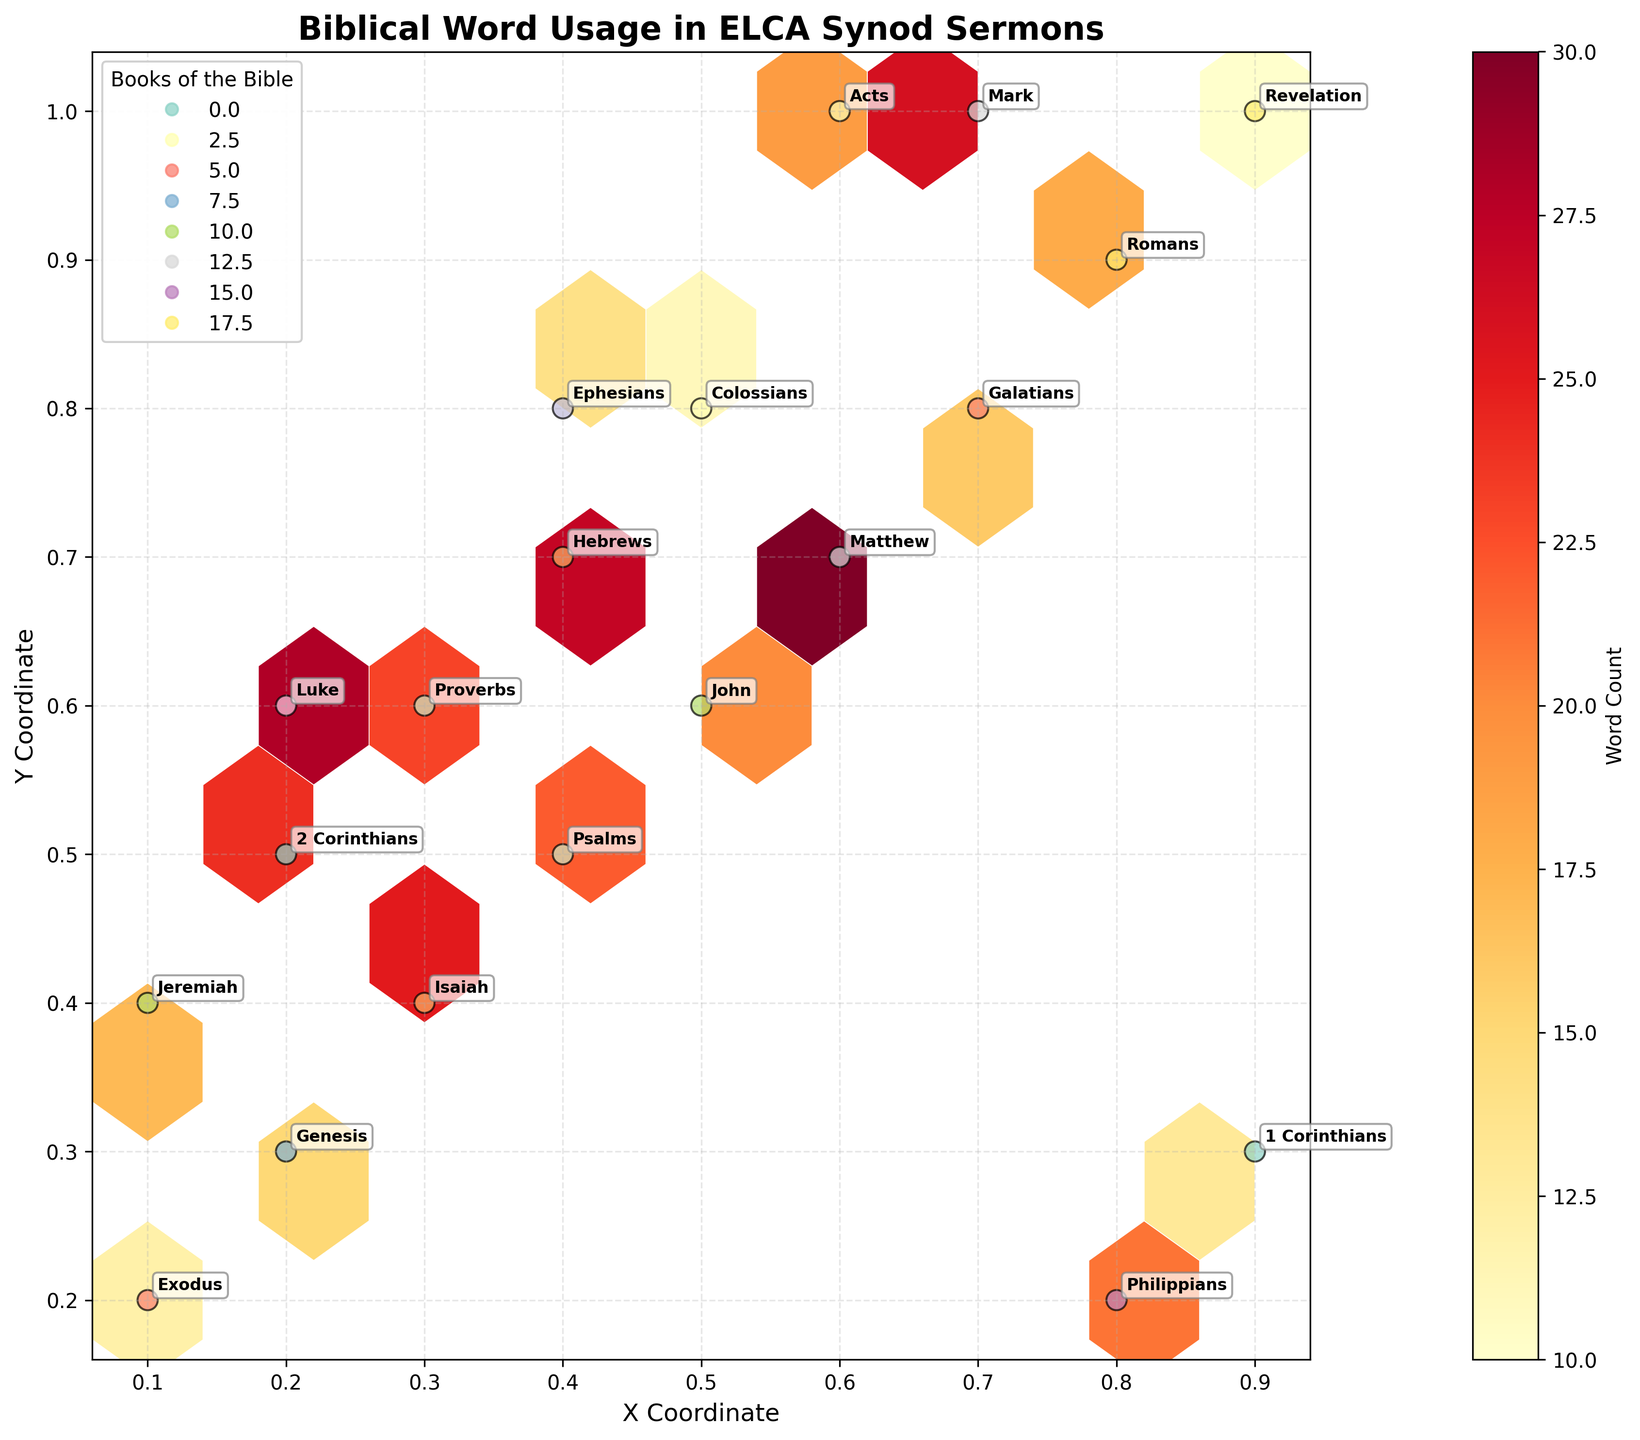What is the title of the hexbin plot? The title of the hexbin plot is written at the top of the figure.
Answer: Biblical Word Usage in ELCA Synod Sermons Which book of the Bible has the highest word count in the sermons based on the plot? Identify the hexbin with the highest count number and note the labeled book of the Bible nearby. The hexbin with the highest count has the label "Matthew".
Answer: Matthew What color represents the book of Psalms in the scatter plot? Look at the color of the scatter points and the corresponding legend for Psalms. The color associated with Psalms in the legend should be the same in the plot.
Answer: Purple (or the color denoted by Psalms in the plot) What is the x and y coordinate with the highest word count of Proverbs? Find the hexbin with the label "Proverbs" and note the coordinates next to it.
Answer: (0.3, 0.6) How many books of the Bible are represented in the plot? Count the unique labels next to each scatter point which corresponds to the books of the Bible.
Answer: 19 Which book of the Bible has a higher word count, Exodus or Revelation, based on the plot? Compare the word counts next to the annotated books "Exodus" and "Revelation". Count for Exodus is 12 and for Revelation is 10.
Answer: Exodus Which book of the Bible is represented by the hexbin with coordinates closest to (0.4, 0.5)? Identify the hexbin around coordinates (0.4, 0.5) and check the book label next to it.
Answer: Psalms Do any books have hexbin counts exactly equal to 20? If yes, which book(s)? Look for hexbin counts with exactly 20 and note the label of the book next to it. The hexbin at this count is labeled "John".
Answer: John What is the word count for 1 Corinthians and what are its coordinates? Find the hexbin labeled "1 Corinthians" and check its word count and coordinates. The count is 13 and the coordinates are (0.9, 0.3).
Answer: 13, (0.9, 0.3) Which book associated with the hexbin closest to the coordinates (0.6, 1.0) has the highest word count? Locate the hexbin closest to (0.6, 1.0) and find its label and word count. The book is "Acts" with a count of 19.
Answer: Acts 